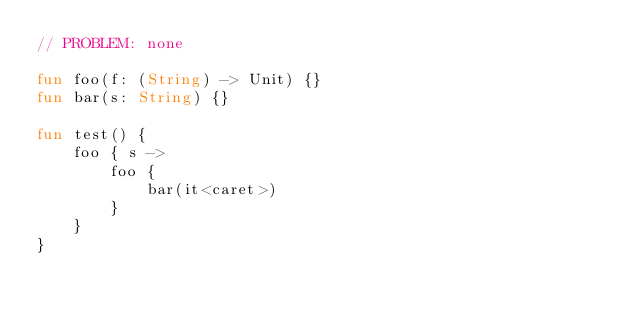Convert code to text. <code><loc_0><loc_0><loc_500><loc_500><_Kotlin_>// PROBLEM: none

fun foo(f: (String) -> Unit) {}
fun bar(s: String) {}

fun test() {
    foo { s ->
        foo {
            bar(it<caret>)
        }
    }
}</code> 